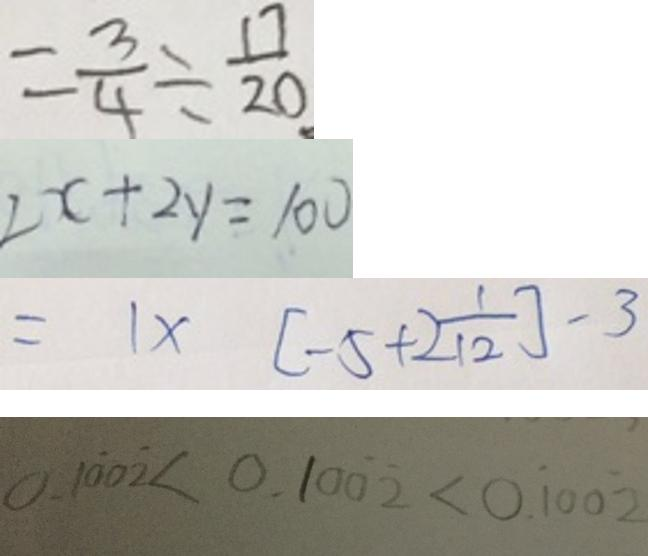<formula> <loc_0><loc_0><loc_500><loc_500>= \frac { 3 } { 4 } \div \frac { 1 7 } { 2 0 } 
 2 x + 2 y = 1 0 0 
 = 1 \times [ - 5 + 2 \frac { 1 } { 1 2 } ] - 3 
 0 . 1 \dot { 0 } 0 \dot { 2 } < 0 . 1 0 \dot { 0 } \dot { 2 } < 0 . \dot { 1 } 0 0 \dot { 2 }</formula> 